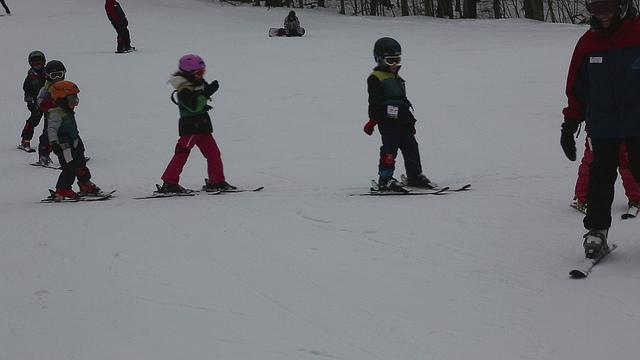Are the people in the picture skiing?
Give a very brief answer. Yes. Is the skier tall?
Quick response, please. No. Is the sun shining in this picture?
Be succinct. No. How many people are there?
Quick response, please. 9. How many people can be seen in this picture?
Write a very short answer. 8. How many people are shown?
Write a very short answer. 9. How many unique people have been photographed for this picture?
Quick response, please. 9. How many children are wearing helmets?
Give a very brief answer. 5. What is the boy riding?
Answer briefly. Skis. Are there more children or adults here?
Give a very brief answer. Children. How many skiers are visible?
Concise answer only. 8. How old are the skiers?
Short answer required. Young. What color are the childs shoes?
Be succinct. Black. Is snowing?
Give a very brief answer. No. Is the boy excited about skiing?
Concise answer only. Yes. Do the children have poles?
Answer briefly. No. Is this person racing?
Give a very brief answer. No. Is the woman a beginning skier?
Answer briefly. Yes. Is this a competition?
Keep it brief. No. What are the people doing?
Write a very short answer. Skiing. How many people are in this group?
Write a very short answer. 6. Are these downhill or cross country skiers?
Answer briefly. Downhill. How many kids in this photo?
Answer briefly. 5. What color are the person's gloves?
Give a very brief answer. Black. Where are the children looking?
Quick response, please. In front of them. How many people in this photo?
Be succinct. 9. What are the children doing?
Keep it brief. Skiing. Is this area densely populated with people?
Keep it brief. Yes. How many people are wearing skis?
Be succinct. 7. How many skis are on the ground?
Give a very brief answer. 14. Is there a snowplougher behind the skiers?
Keep it brief. No. Are these people going uphill or downhill?
Quick response, please. Downhill. What color is the helmet?
Answer briefly. Pink. Are there atomic skis in this photo?
Be succinct. No. Are the people on skis?
Answer briefly. Yes. Are there buildings in the background?
Short answer required. No. 